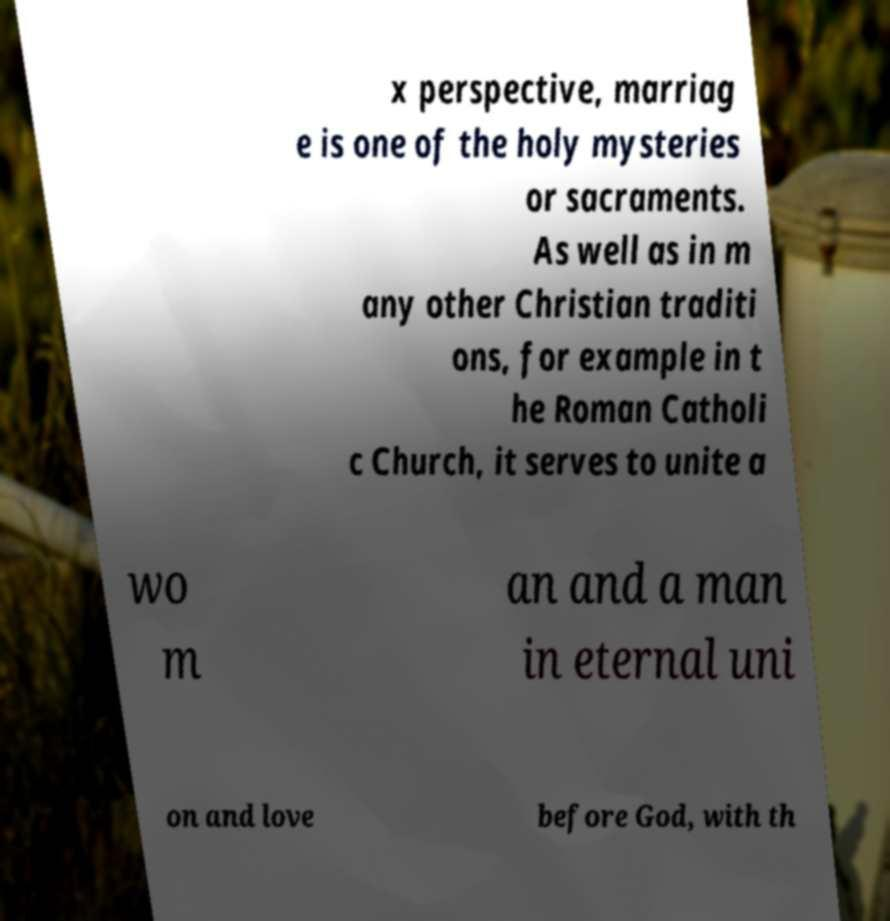What messages or text are displayed in this image? I need them in a readable, typed format. x perspective, marriag e is one of the holy mysteries or sacraments. As well as in m any other Christian traditi ons, for example in t he Roman Catholi c Church, it serves to unite a wo m an and a man in eternal uni on and love before God, with th 